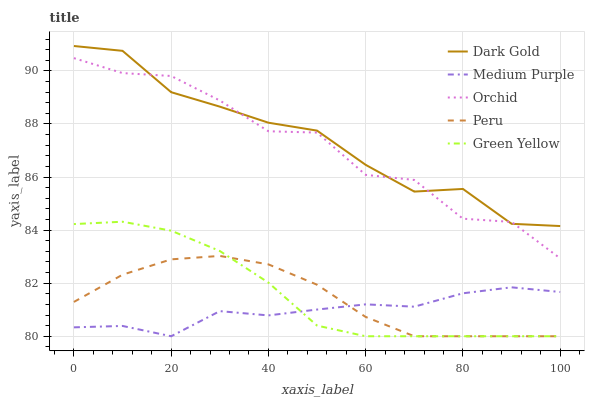Does Medium Purple have the minimum area under the curve?
Answer yes or no. Yes. Does Dark Gold have the maximum area under the curve?
Answer yes or no. Yes. Does Green Yellow have the minimum area under the curve?
Answer yes or no. No. Does Green Yellow have the maximum area under the curve?
Answer yes or no. No. Is Green Yellow the smoothest?
Answer yes or no. Yes. Is Orchid the roughest?
Answer yes or no. Yes. Is Orchid the smoothest?
Answer yes or no. No. Is Green Yellow the roughest?
Answer yes or no. No. Does Medium Purple have the lowest value?
Answer yes or no. Yes. Does Orchid have the lowest value?
Answer yes or no. No. Does Dark Gold have the highest value?
Answer yes or no. Yes. Does Green Yellow have the highest value?
Answer yes or no. No. Is Green Yellow less than Dark Gold?
Answer yes or no. Yes. Is Dark Gold greater than Medium Purple?
Answer yes or no. Yes. Does Medium Purple intersect Peru?
Answer yes or no. Yes. Is Medium Purple less than Peru?
Answer yes or no. No. Is Medium Purple greater than Peru?
Answer yes or no. No. Does Green Yellow intersect Dark Gold?
Answer yes or no. No. 